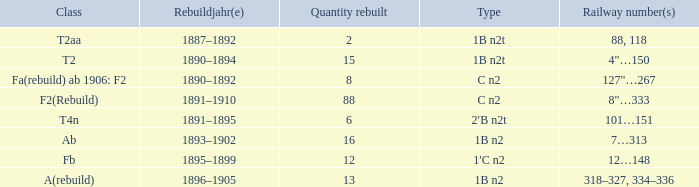What is the total of quantity rebuilt if the type is 1B N2T and the railway number is 88, 118? 1.0. 